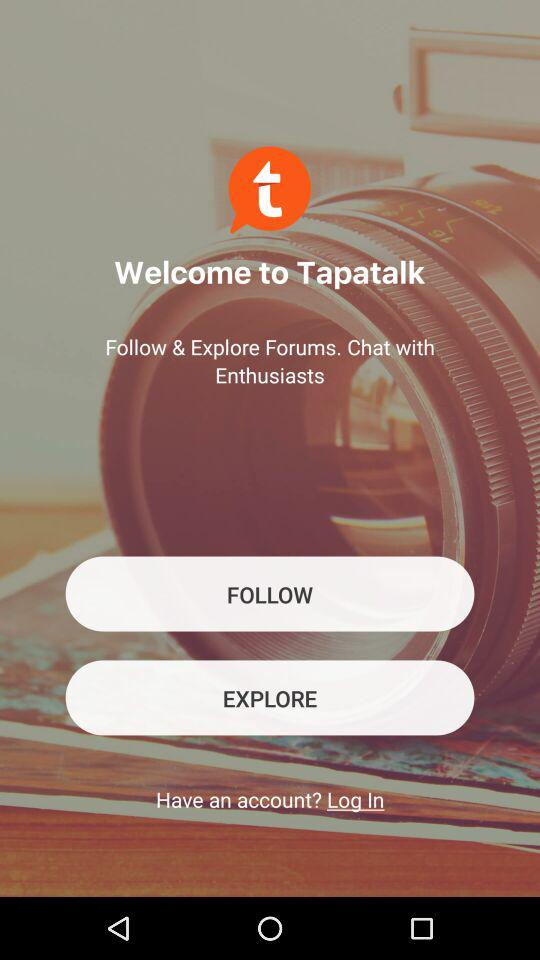What is the name of the application? The name of the application is "Tapatalk". 